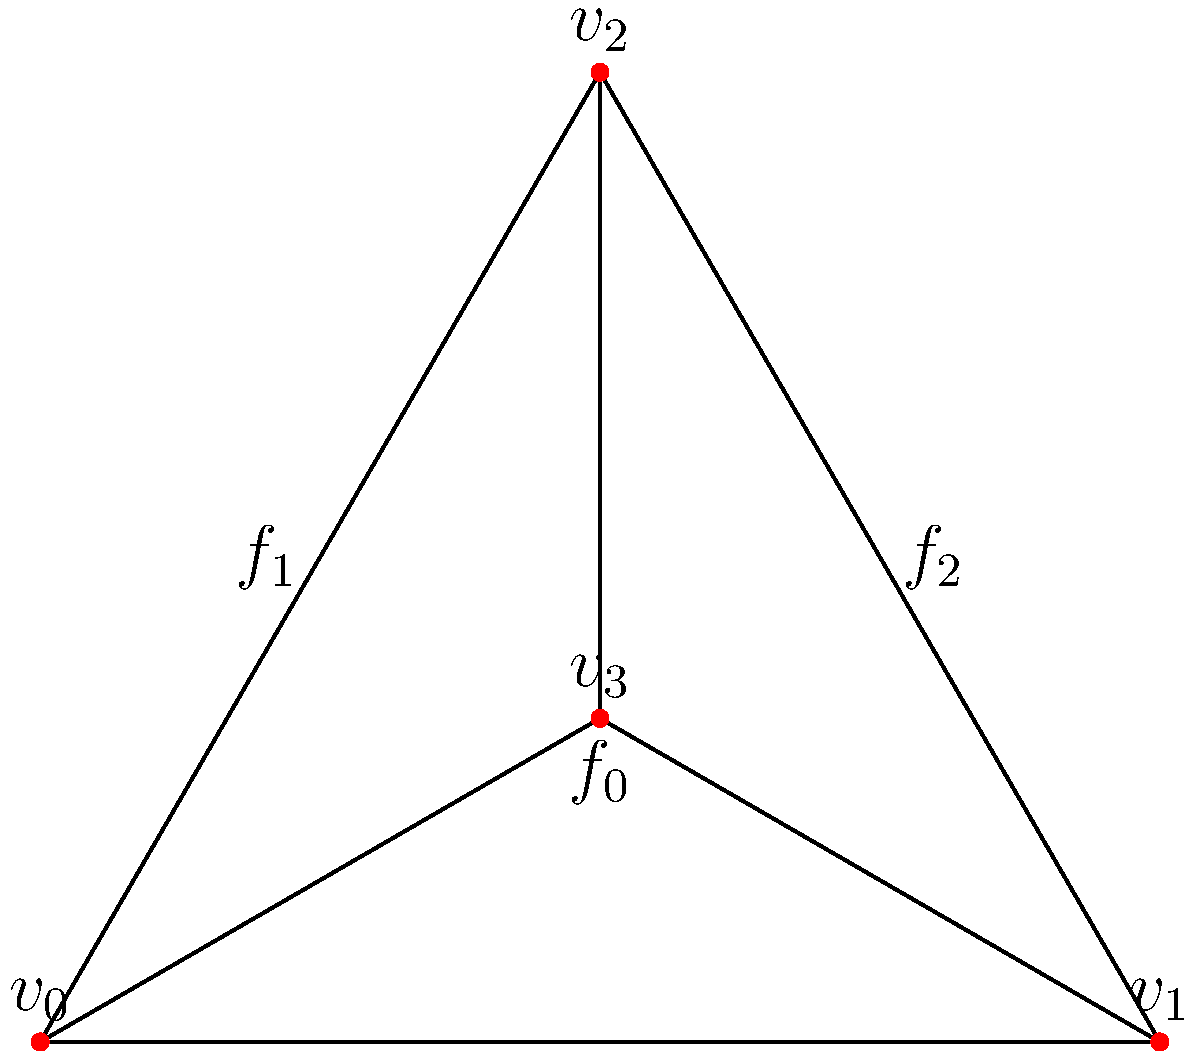Given a simplicial complex constructed from word embeddings of ancient manuscripts, where each vertex represents a unique word and edges connect semantically related words, the resulting structure is shown in the diagram. Calculate the Euler characteristic of this simplicial complex and interpret its significance in the context of analyzing historical texts. To calculate the Euler characteristic and interpret its significance, we'll follow these steps:

1) Count the components of the simplicial complex:
   - Vertices (V): 4 ($v_0$, $v_1$, $v_2$, $v_3$)
   - Edges (E): 5 ($v_0v_1$, $v_0v_2$, $v_1v_2$, $v_0v_3$, $v_1v_3$, $v_2v_3$)
   - Faces (F): 3 ($f_0$, $f_1$, $f_2$)

2) Apply the Euler characteristic formula:
   $\chi = V - E + F$
   $\chi = 4 - 5 + 3 = 2$

3) Interpretation in the context of analyzing historical texts:

   a) Topological insight: The Euler characteristic of 2 suggests that this simplicial complex is homeomorphic to a sphere. In the context of word embeddings, this could indicate a cohesive and well-connected semantic structure in the analyzed text.

   b) Semantic relationships: The vertices represent unique words, and edges represent semantic relationships. The presence of triangular faces ($f_0$, $f_1$, $f_2$) suggests strong semantic connections between groups of three words, which could indicate key concepts or themes in the historical text.

   c) Linguistic structure: The simplicial complex's structure provides insights into the text's linguistic complexity. A higher number of faces relative to edges and vertices suggests a rich interconnectedness of concepts, which could be characteristic of sophisticated or scholarly historical texts.

   d) Comparative analysis: The Euler characteristic can be used as a metric for comparing different historical texts or sections within a text. A higher χ might indicate a more interconnected or complex semantic structure.

   e) Temporal analysis: If applied to texts from different time periods, changes in the Euler characteristic could reflect evolution in language use or conceptual complexity over time.

   f) Identifying key concepts: Vertices with high connectivity (like $v_3$ in this case) might represent central or frequently occurring terms in the text, potentially highlighting important themes or concepts.
Answer: $\chi = 2$; indicates spherical topology, suggesting cohesive semantic structure in the historical text. 